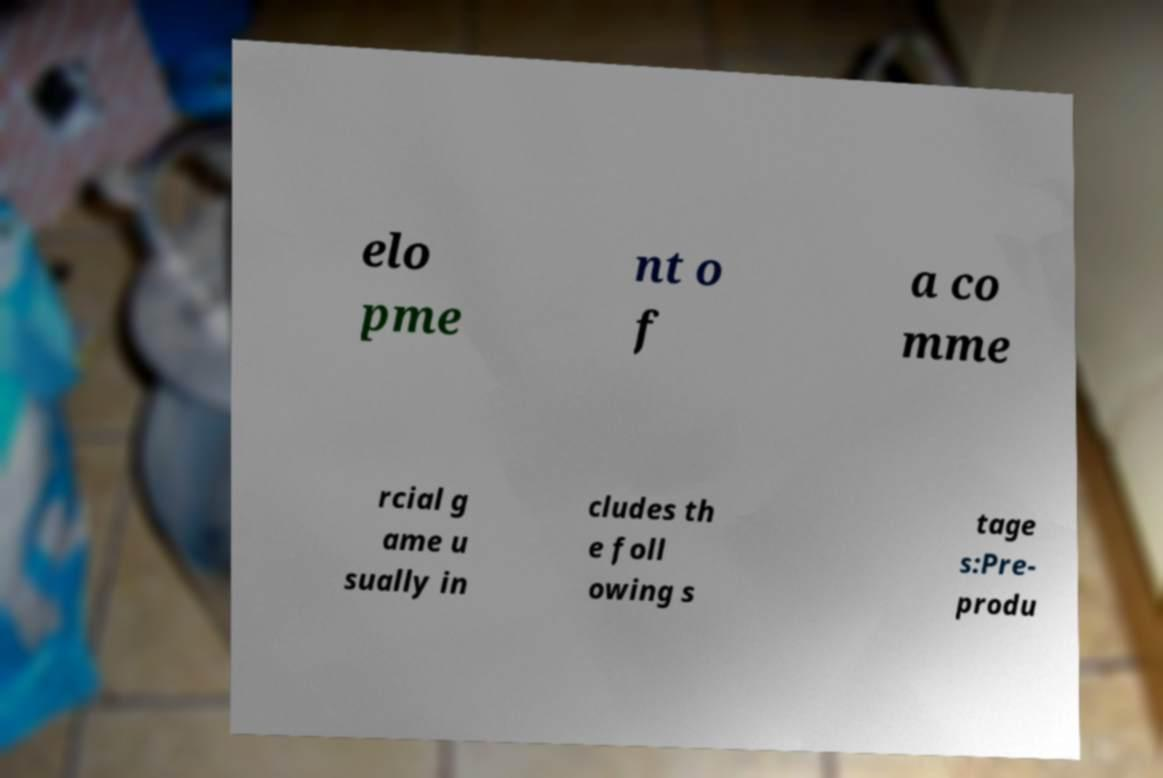For documentation purposes, I need the text within this image transcribed. Could you provide that? elo pme nt o f a co mme rcial g ame u sually in cludes th e foll owing s tage s:Pre- produ 